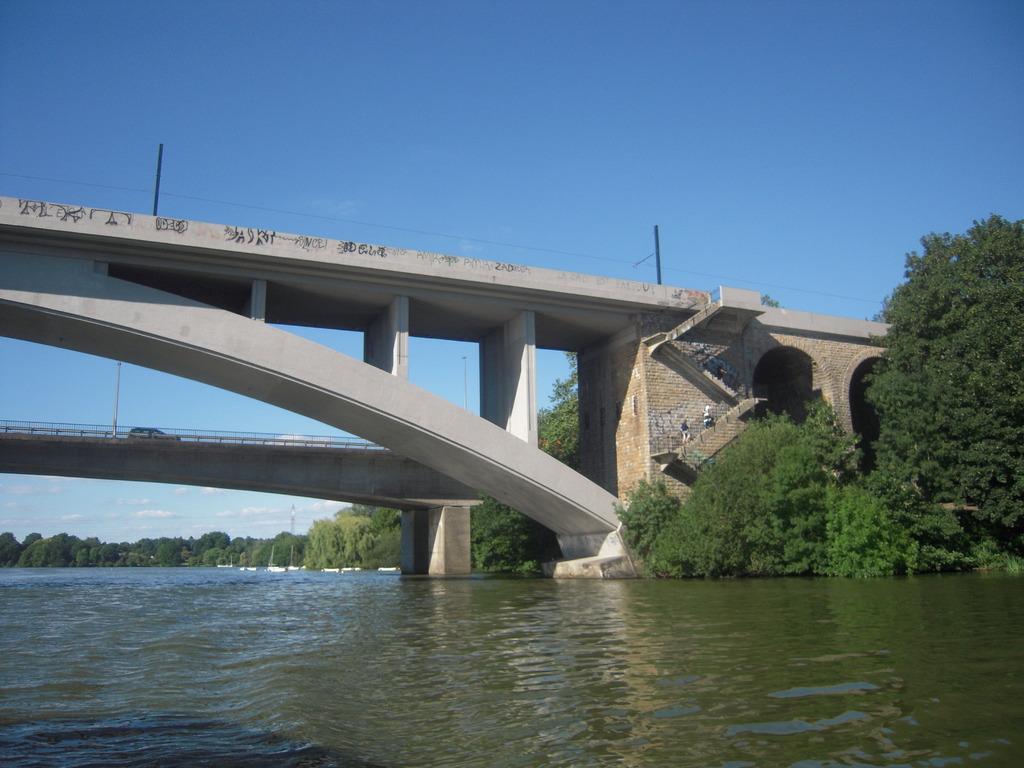In one or two sentences, can you explain what this image depicts? In the foreground of the picture there is a water body. In the center of the picture there are trees, staircases, people, bridges and vehicle. In the background there are trees and boats. At the top there are current poles and cable. Sky is sunny. 